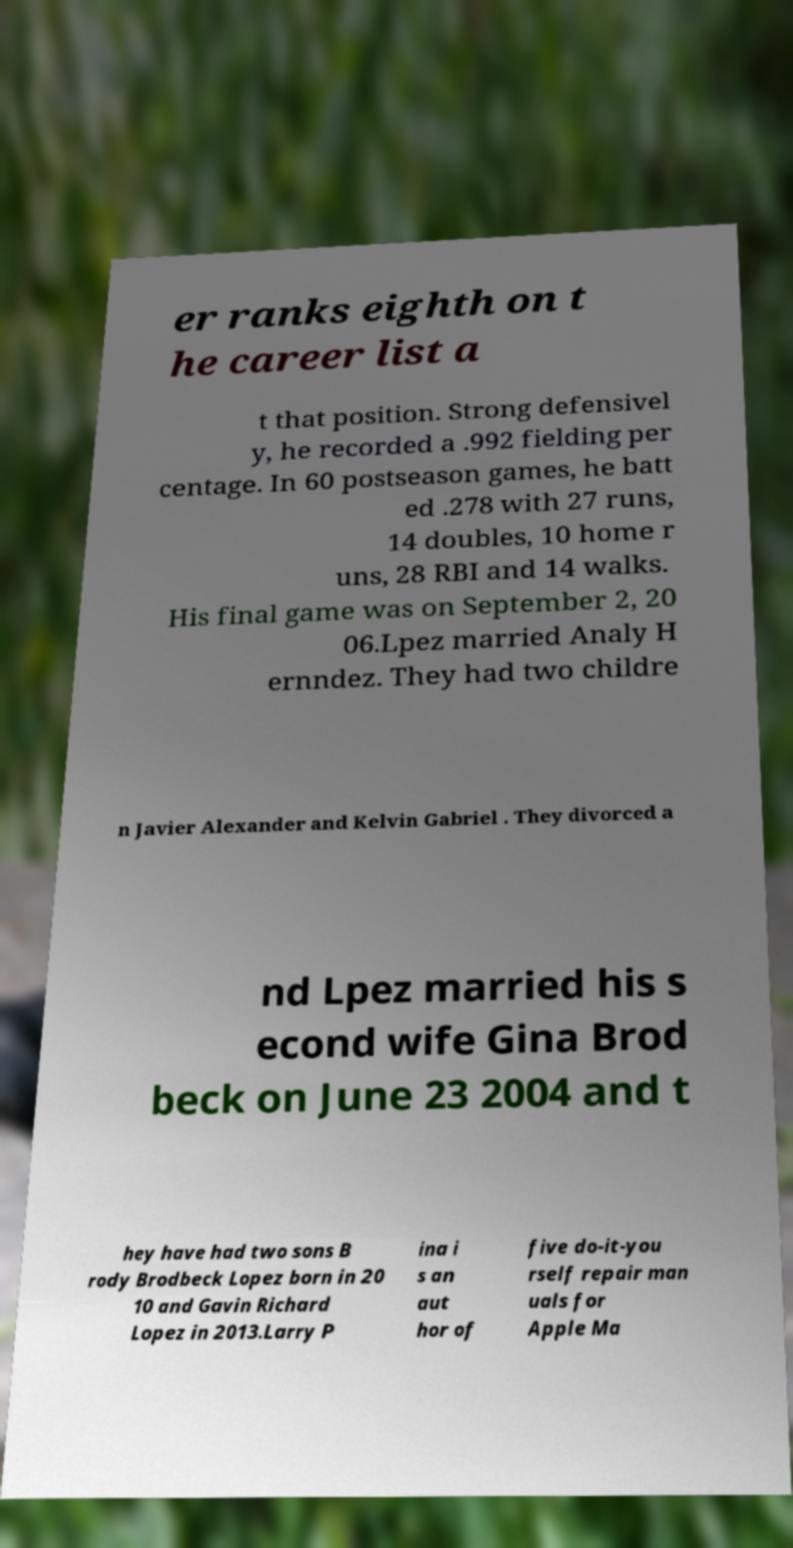I need the written content from this picture converted into text. Can you do that? er ranks eighth on t he career list a t that position. Strong defensivel y, he recorded a .992 fielding per centage. In 60 postseason games, he batt ed .278 with 27 runs, 14 doubles, 10 home r uns, 28 RBI and 14 walks. His final game was on September 2, 20 06.Lpez married Analy H ernndez. They had two childre n Javier Alexander and Kelvin Gabriel . They divorced a nd Lpez married his s econd wife Gina Brod beck on June 23 2004 and t hey have had two sons B rody Brodbeck Lopez born in 20 10 and Gavin Richard Lopez in 2013.Larry P ina i s an aut hor of five do-it-you rself repair man uals for Apple Ma 